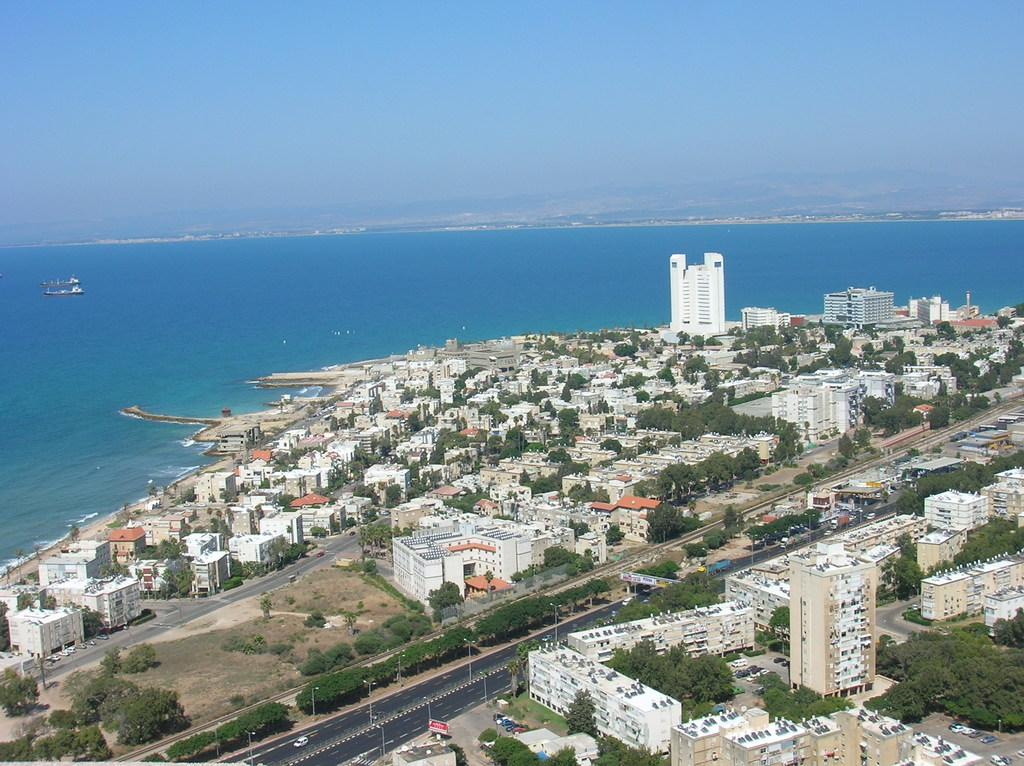What can be seen in the foreground of the image? In the foreground of the image, there are buildings, trees, roads, and vehicles. Can you describe the vegetation in the foreground? Yes, there are trees in the foreground of the image. What type of transportation is visible in the foreground? Vehicles are visible in the foreground of the image. What is visible in the background of the image? In the background of the image, there are ships visible on a water body. What is the condition of the sky in the image? The sky is clear in the image. How many bananas are hanging from the trees in the image? There are no bananas visible in the image; only trees are present. Are there any chickens walking on the roads in the image? There are no chickens visible in the image; only vehicles are present on the roads. 